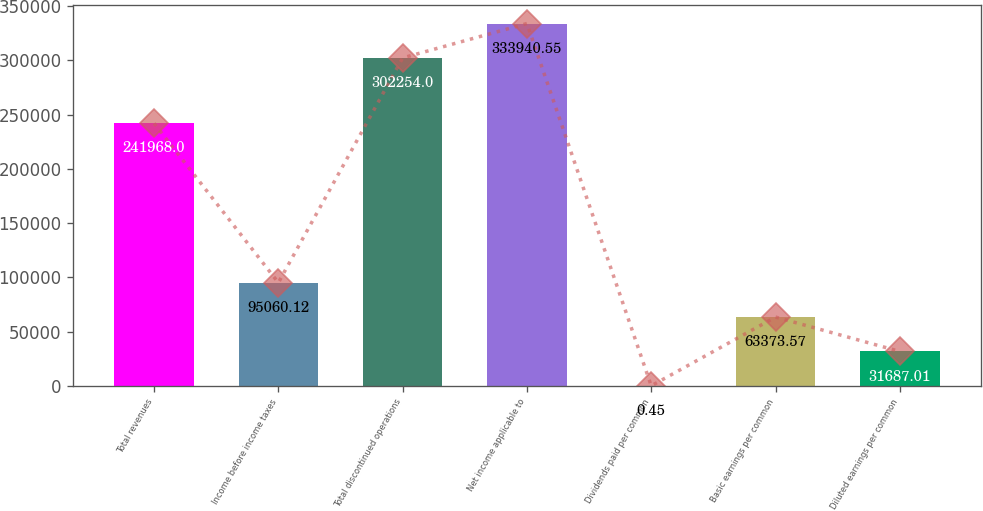Convert chart. <chart><loc_0><loc_0><loc_500><loc_500><bar_chart><fcel>Total revenues<fcel>Income before income taxes<fcel>Total discontinued operations<fcel>Net income applicable to<fcel>Dividends paid per common<fcel>Basic earnings per common<fcel>Diluted earnings per common<nl><fcel>241968<fcel>95060.1<fcel>302254<fcel>333941<fcel>0.45<fcel>63373.6<fcel>31687<nl></chart> 